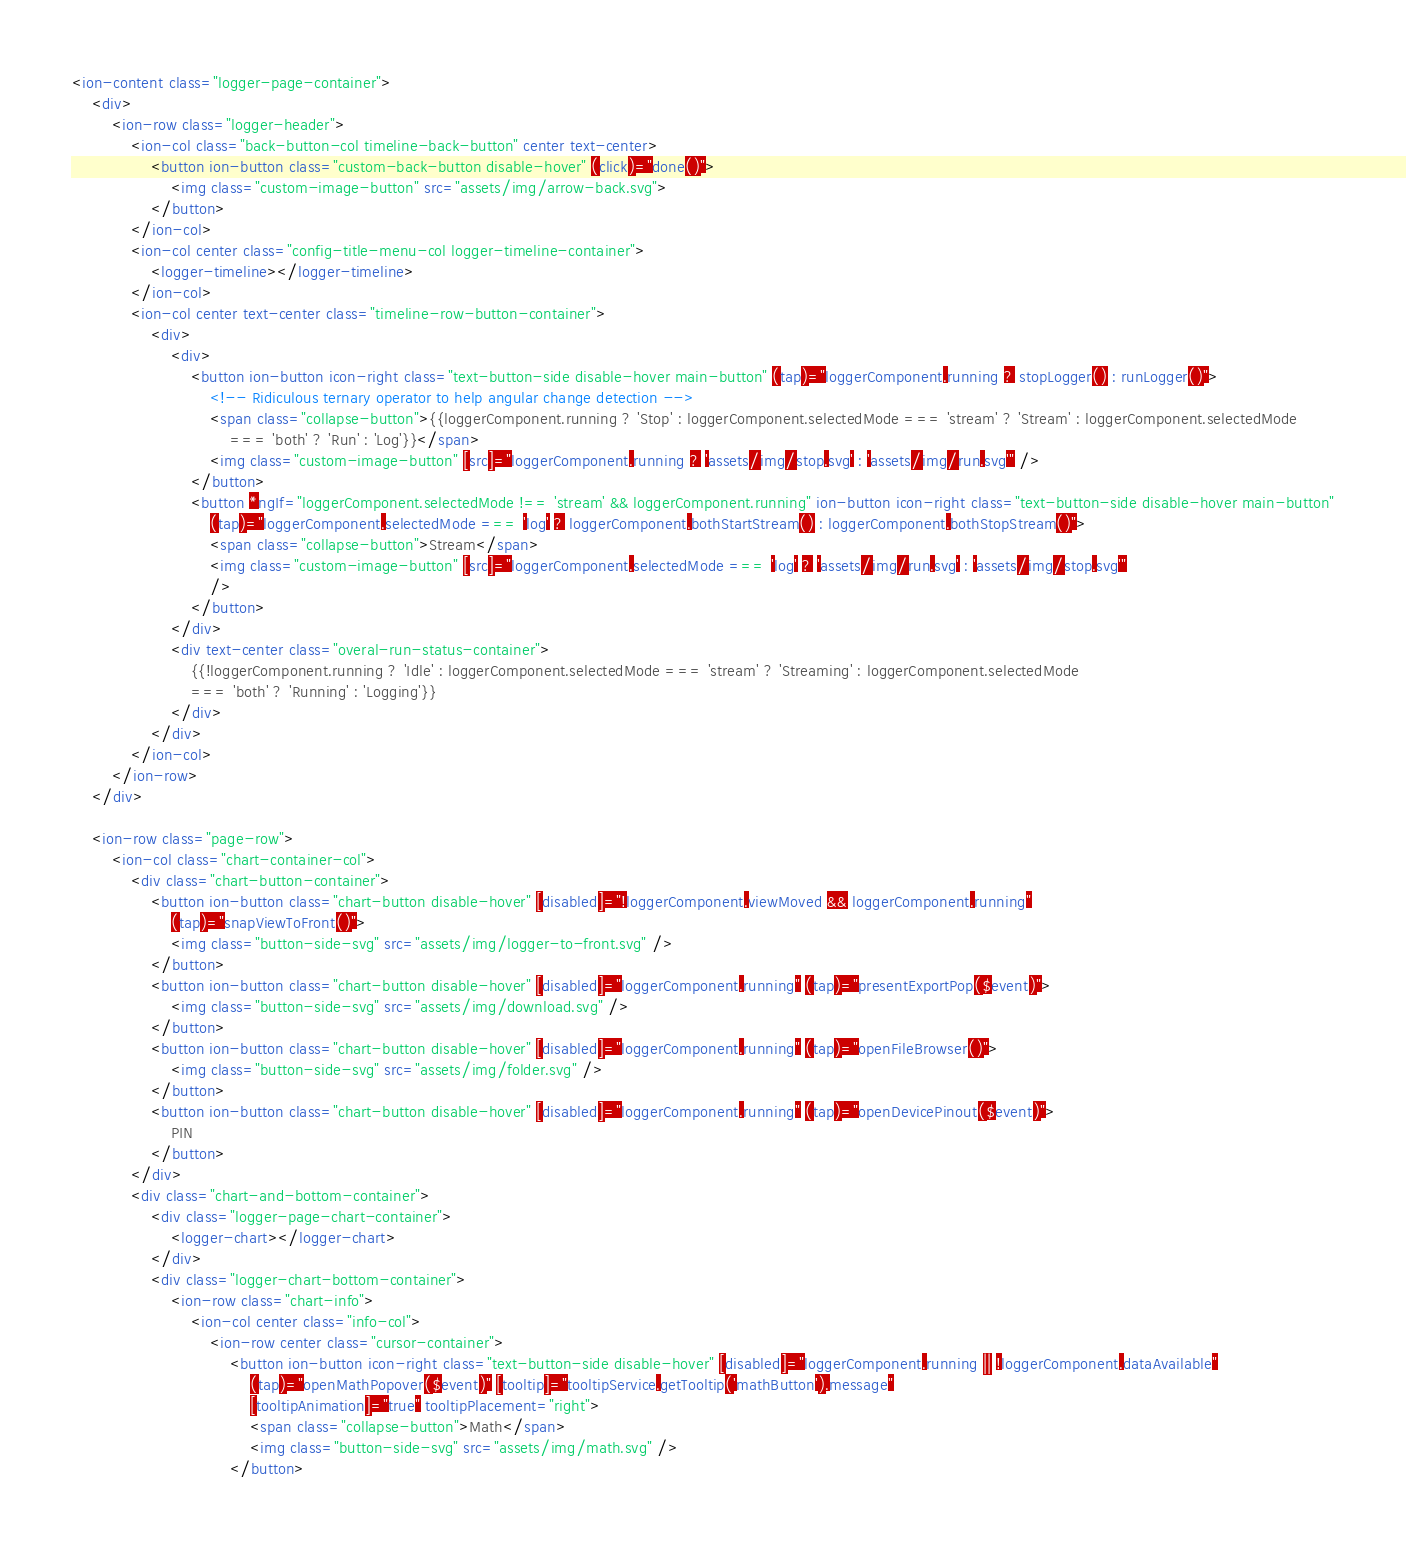Convert code to text. <code><loc_0><loc_0><loc_500><loc_500><_HTML_><ion-content class="logger-page-container">
    <div>
        <ion-row class="logger-header">
            <ion-col class="back-button-col timeline-back-button" center text-center>
                <button ion-button class="custom-back-button disable-hover" (click)="done()">
                    <img class="custom-image-button" src="assets/img/arrow-back.svg">
                </button>
            </ion-col>
            <ion-col center class="config-title-menu-col logger-timeline-container">
                <logger-timeline></logger-timeline>
            </ion-col>
            <ion-col center text-center class="timeline-row-button-container">
                <div>
                    <div>
                        <button ion-button icon-right class="text-button-side disable-hover main-button" (tap)="loggerComponent.running ? stopLogger() : runLogger()">
                            <!-- Ridiculous ternary operator to help angular change detection -->
                            <span class="collapse-button">{{loggerComponent.running ? 'Stop' : loggerComponent.selectedMode === 'stream' ? 'Stream' : loggerComponent.selectedMode
                                === 'both' ? 'Run' : 'Log'}}</span>
                            <img class="custom-image-button" [src]="loggerComponent.running ? 'assets/img/stop.svg' : 'assets/img/run.svg'" />
                        </button>
                        <button *ngIf="loggerComponent.selectedMode !== 'stream' && loggerComponent.running" ion-button icon-right class="text-button-side disable-hover main-button"
                            (tap)="loggerComponent.selectedMode === 'log' ? loggerComponent.bothStartStream() : loggerComponent.bothStopStream()">
                            <span class="collapse-button">Stream</span>
                            <img class="custom-image-button" [src]="loggerComponent.selectedMode === 'log' ? 'assets/img/run.svg' : 'assets/img/stop.svg'"
                            />
                        </button>
                    </div>
                    <div text-center class="overal-run-status-container">
                        {{!loggerComponent.running ? 'Idle' : loggerComponent.selectedMode === 'stream' ? 'Streaming' : loggerComponent.selectedMode
                        === 'both' ? 'Running' : 'Logging'}}
                    </div>
                </div>
            </ion-col>
        </ion-row>
    </div>

    <ion-row class="page-row">
        <ion-col class="chart-container-col">
            <div class="chart-button-container">
                <button ion-button class="chart-button disable-hover" [disabled]="!loggerComponent.viewMoved && loggerComponent.running"
                    (tap)="snapViewToFront()">
                    <img class="button-side-svg" src="assets/img/logger-to-front.svg" />
                </button>
                <button ion-button class="chart-button disable-hover" [disabled]="loggerComponent.running" (tap)="presentExportPop($event)">
                    <img class="button-side-svg" src="assets/img/download.svg" />
                </button>
                <button ion-button class="chart-button disable-hover" [disabled]="loggerComponent.running" (tap)="openFileBrowser()">
                    <img class="button-side-svg" src="assets/img/folder.svg" />
                </button>
                <button ion-button class="chart-button disable-hover" [disabled]="loggerComponent.running" (tap)="openDevicePinout($event)">
                    PIN
                </button>
            </div>
            <div class="chart-and-bottom-container">
                <div class="logger-page-chart-container">
                    <logger-chart></logger-chart>
                </div>
                <div class="logger-chart-bottom-container">
                    <ion-row class="chart-info">
                        <ion-col center class="info-col">
                            <ion-row center class="cursor-container">
                                <button ion-button icon-right class="text-button-side disable-hover" [disabled]="loggerComponent.running || !loggerComponent.dataAvailable"
                                    (tap)="openMathPopover($event)" [tooltip]="tooltipService.getTooltip('mathButton').message"
                                    [tooltipAnimation]="true" tooltipPlacement="right">
                                    <span class="collapse-button">Math</span>
                                    <img class="button-side-svg" src="assets/img/math.svg" />
                                </button></code> 